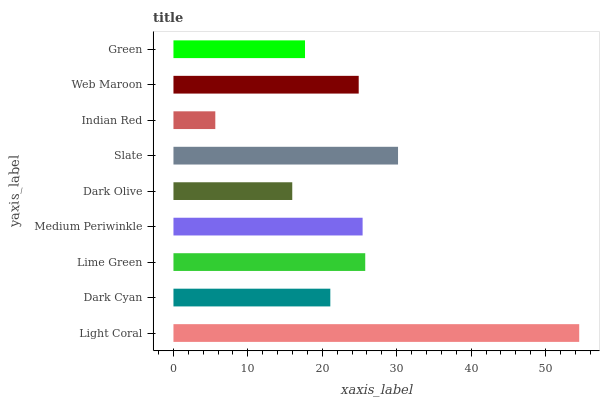Is Indian Red the minimum?
Answer yes or no. Yes. Is Light Coral the maximum?
Answer yes or no. Yes. Is Dark Cyan the minimum?
Answer yes or no. No. Is Dark Cyan the maximum?
Answer yes or no. No. Is Light Coral greater than Dark Cyan?
Answer yes or no. Yes. Is Dark Cyan less than Light Coral?
Answer yes or no. Yes. Is Dark Cyan greater than Light Coral?
Answer yes or no. No. Is Light Coral less than Dark Cyan?
Answer yes or no. No. Is Web Maroon the high median?
Answer yes or no. Yes. Is Web Maroon the low median?
Answer yes or no. Yes. Is Dark Olive the high median?
Answer yes or no. No. Is Lime Green the low median?
Answer yes or no. No. 